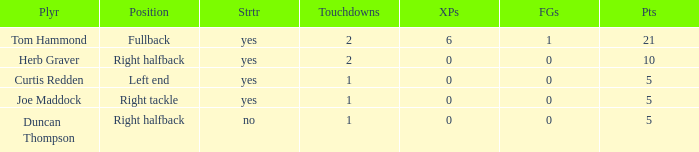Name the fewest touchdowns 1.0. 